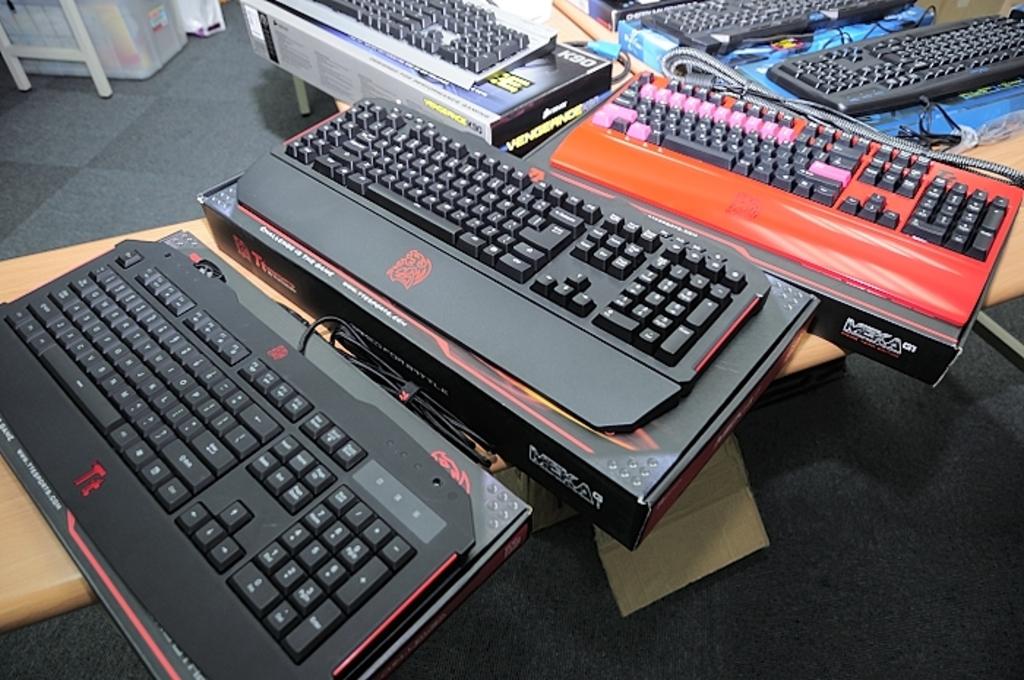What brand are these?
Ensure brevity in your answer.  Meka. 